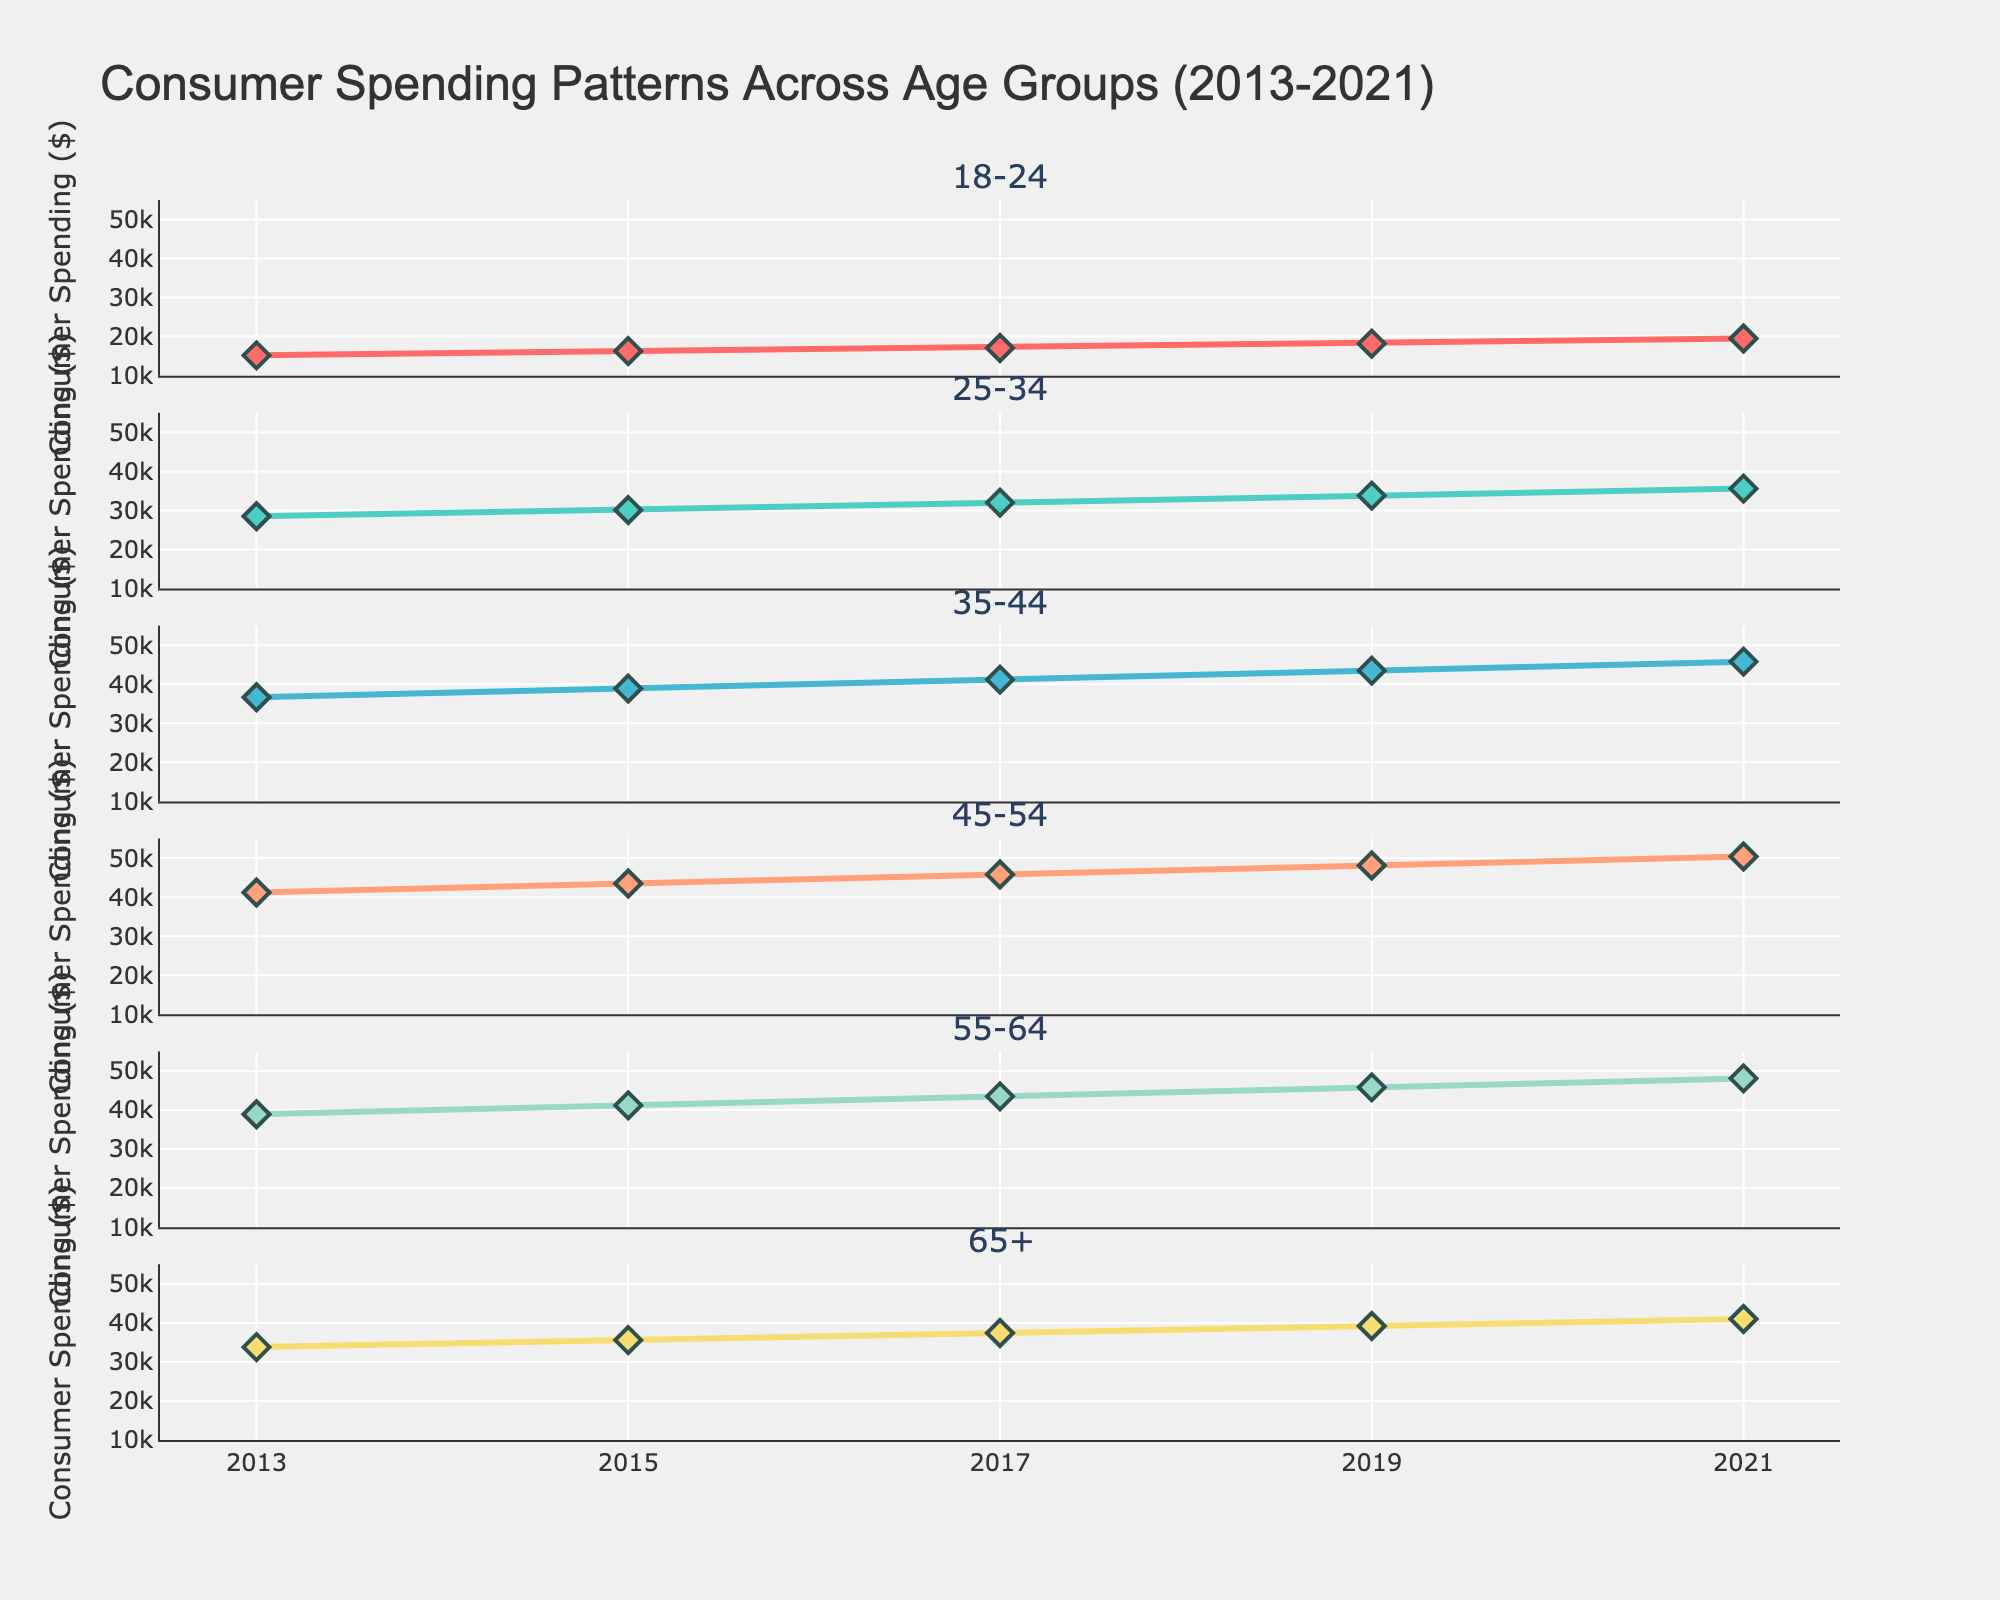What's the title of the figure? The title is usually displayed at the top of the chart and provides a clear idea of what the visual data represents. In this case, the title reads "Consumer Spending Patterns Across Age Groups (2013-2021)".
Answer: Consumer Spending Patterns Across Age Groups (2013-2021) How many age groups are compared in the figure? Count the number of subplot titles or the different sections in the figure. There are six unique age groups being compared, which are labeled in the subplot titles.
Answer: Six What are the years displayed on the x-axis? Look at the labels along the horizontal axis, which shows the range of years the data covers. Specifically, the years listed are 2013, 2015, 2017, 2019, and 2021.
Answer: 2013, 2015, 2017, 2019, 2021 Which age group shows the most significant increase in consumer spending from 2013 to 2021? Compare the starting and ending points of each age group's plot line. The age group 45-54 shows the most significant increase (from $41,200 to $50,400), indicated by the steep upward trajectory of the line.
Answer: 45-54 What is the consumer spending in 2021 for the 65+ age group? Look at the subplot corresponding to the 65+ age group and find the y-axis value where the line ends in 2021. The value is $41,000.
Answer: $41,000 Which two age groups had similar spending in 2021? Compare the last data points of all age groups in 2021. The 35-44 and 55-64 age groups had spending values of $45,800 and $48,100 respectively, which are relatively close to each other compared to other groups.
Answer: 35-44 and 55-64 What is the difference in consumer spending between the age groups 18-24 and 45-54 in 2021? Find the y-values for each age group in 2021: for 18-24 it's $19,500 and for 45-54 it's $50,400. Calculate the difference: $50,400 - $19,500 = $30,900.
Answer: $30,900 Which age group had the least increase in consumer spending from 2013 to 2021? Calculate the differences for each age group by subtracting their 2021 values from their 2013 values. The least increase is seen in the 65+ age group, from $33,800 to $41,000, which is an increase of $7,200.
Answer: 65+ Does any age group show a decrease in consumer spending over the period? Examine the trends of each line. None of the lines show a decline; all lines show a steady increase, indicating no age group's consumer spending decreased from 2013 to 2021.
Answer: No What is the average consumer spending of the age group 25-34 over the years shown? Calculate the average by summing the values for the age group 25-34 (28,500 + 30,100 + 32,000 + 33,800 + 35,600) and divide by the number of years (5). Average = (28,500 + 30,100 + 32,000 + 33,800 + 35,600) / 5 = 32,000.
Answer: 32,000 